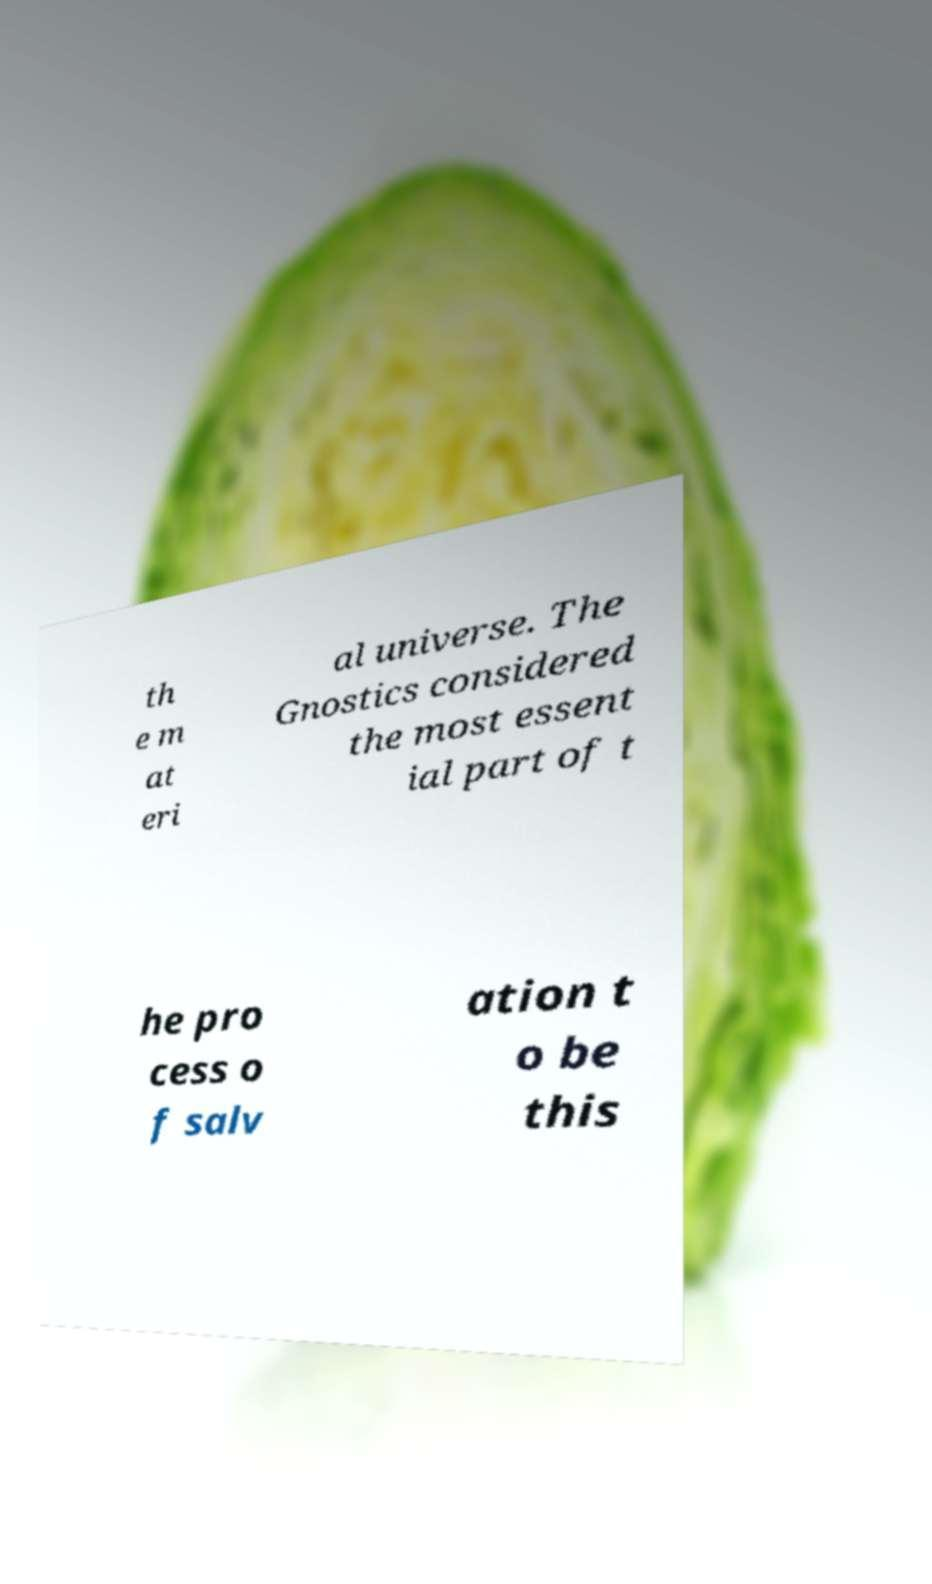What messages or text are displayed in this image? I need them in a readable, typed format. th e m at eri al universe. The Gnostics considered the most essent ial part of t he pro cess o f salv ation t o be this 